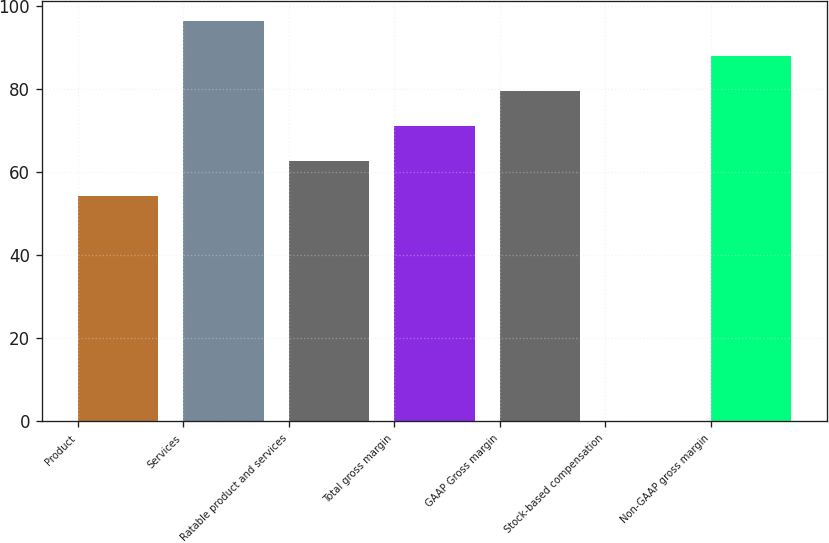Convert chart to OTSL. <chart><loc_0><loc_0><loc_500><loc_500><bar_chart><fcel>Product<fcel>Services<fcel>Ratable product and services<fcel>Total gross margin<fcel>GAAP Gross margin<fcel>Stock-based compensation<fcel>Non-GAAP gross margin<nl><fcel>54.3<fcel>96.35<fcel>62.71<fcel>71.12<fcel>79.53<fcel>0.2<fcel>87.94<nl></chart> 